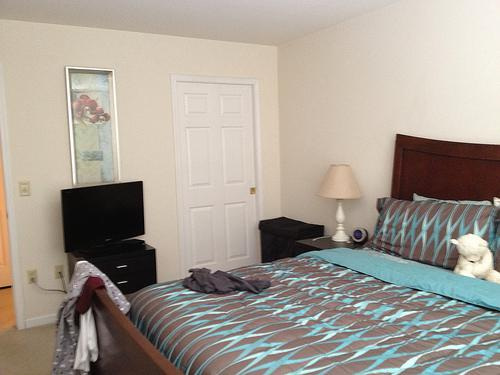Question: what color is the blanket?
Choices:
A. Green.
B. Orange.
C. Purple.
D. Blue, white and gray.
Answer with the letter. Answer: D Question: what is leaned against the pillow?
Choices:
A. A teddy bear.
B. Stuffed animals.
C. Throw pillows.
D. More pillows.
Answer with the letter. Answer: A Question: when will the bed be unmade?
Choices:
A. When the owners go to sleep.
B. When its slept in.
C. When the kids jump on it.
D. After a good nights sleep.
Answer with the letter. Answer: A Question: where is the tv?
Choices:
A. On the nightstand.
B. Mounted on the wall.
C. The large screen on the wall.
D. On top of desk.
Answer with the letter. Answer: A Question: what is the tv plugged into?
Choices:
A. Wall outlet.
B. Cable jack.
C. The wall.
D. TV jack.
Answer with the letter. Answer: C 